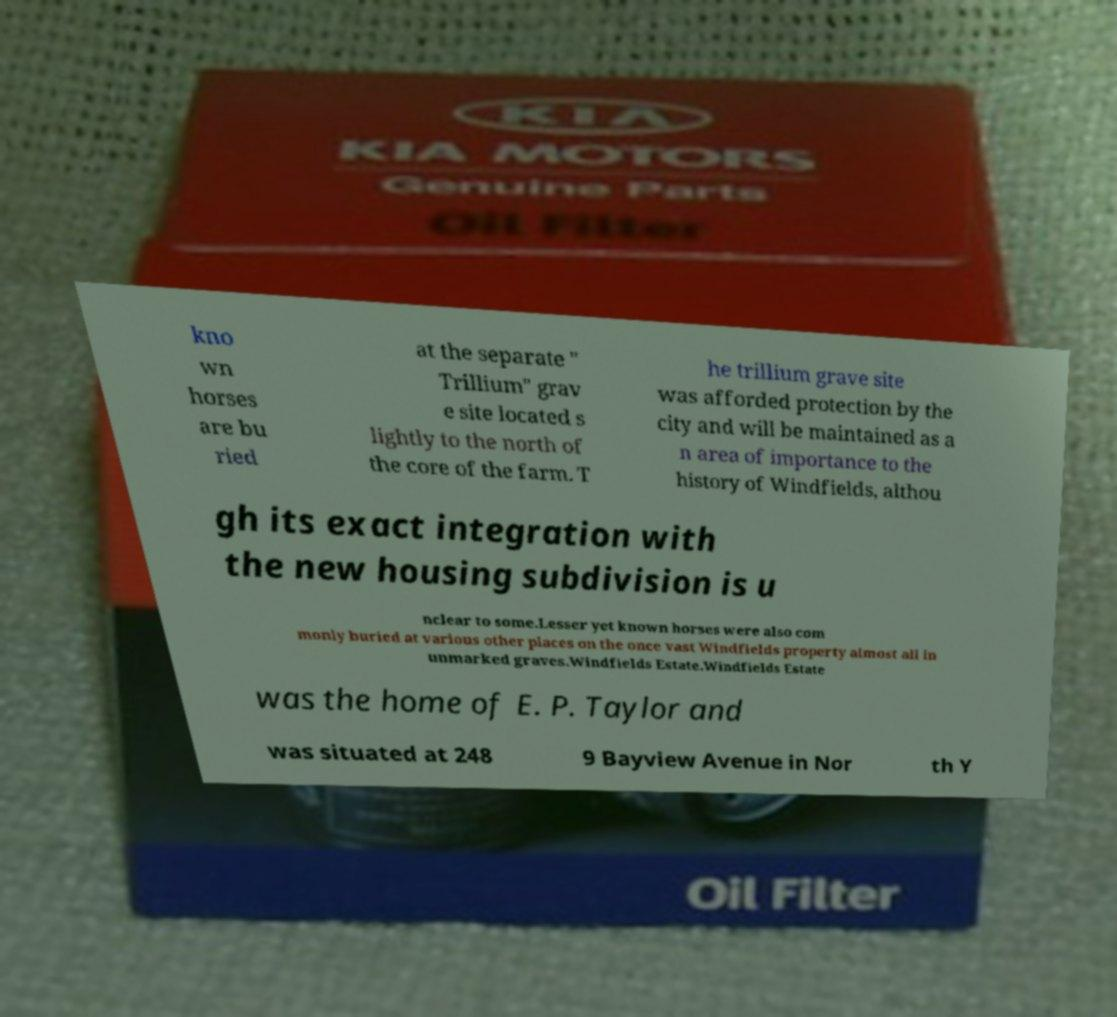Please identify and transcribe the text found in this image. kno wn horses are bu ried at the separate " Trillium" grav e site located s lightly to the north of the core of the farm. T he trillium grave site was afforded protection by the city and will be maintained as a n area of importance to the history of Windfields, althou gh its exact integration with the new housing subdivision is u nclear to some.Lesser yet known horses were also com monly buried at various other places on the once vast Windfields property almost all in unmarked graves.Windfields Estate.Windfields Estate was the home of E. P. Taylor and was situated at 248 9 Bayview Avenue in Nor th Y 